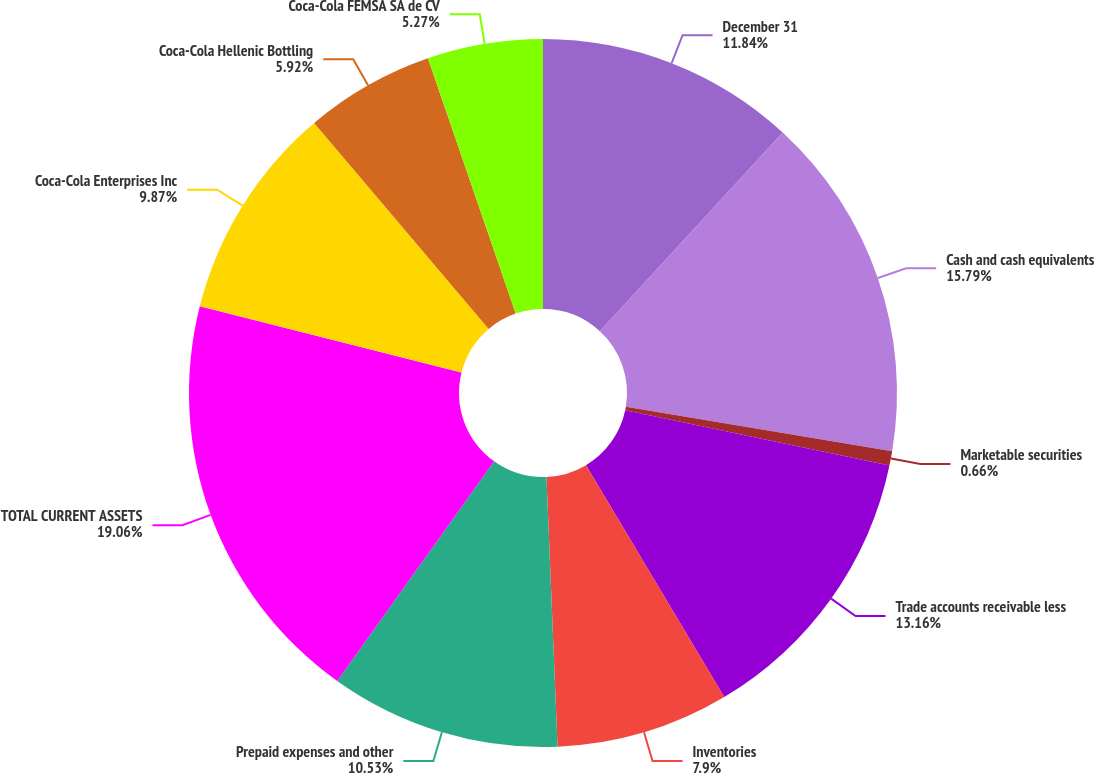Convert chart to OTSL. <chart><loc_0><loc_0><loc_500><loc_500><pie_chart><fcel>December 31<fcel>Cash and cash equivalents<fcel>Marketable securities<fcel>Trade accounts receivable less<fcel>Inventories<fcel>Prepaid expenses and other<fcel>TOTAL CURRENT ASSETS<fcel>Coca-Cola Enterprises Inc<fcel>Coca-Cola Hellenic Bottling<fcel>Coca-Cola FEMSA SA de CV<nl><fcel>11.84%<fcel>15.79%<fcel>0.66%<fcel>13.16%<fcel>7.9%<fcel>10.53%<fcel>19.07%<fcel>9.87%<fcel>5.92%<fcel>5.27%<nl></chart> 